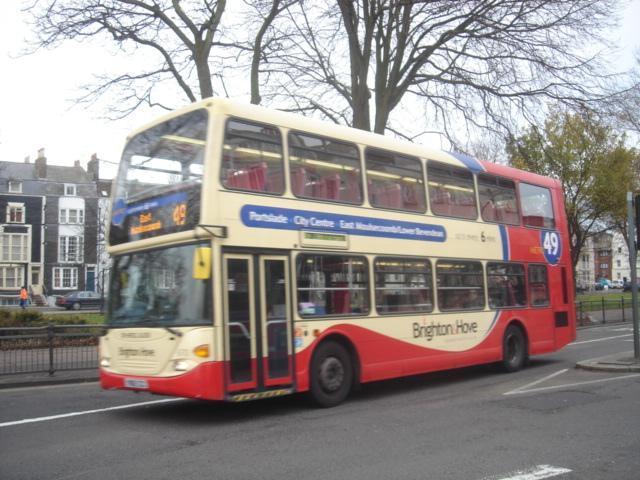How many buses are in the photo?
Give a very brief answer. 1. 